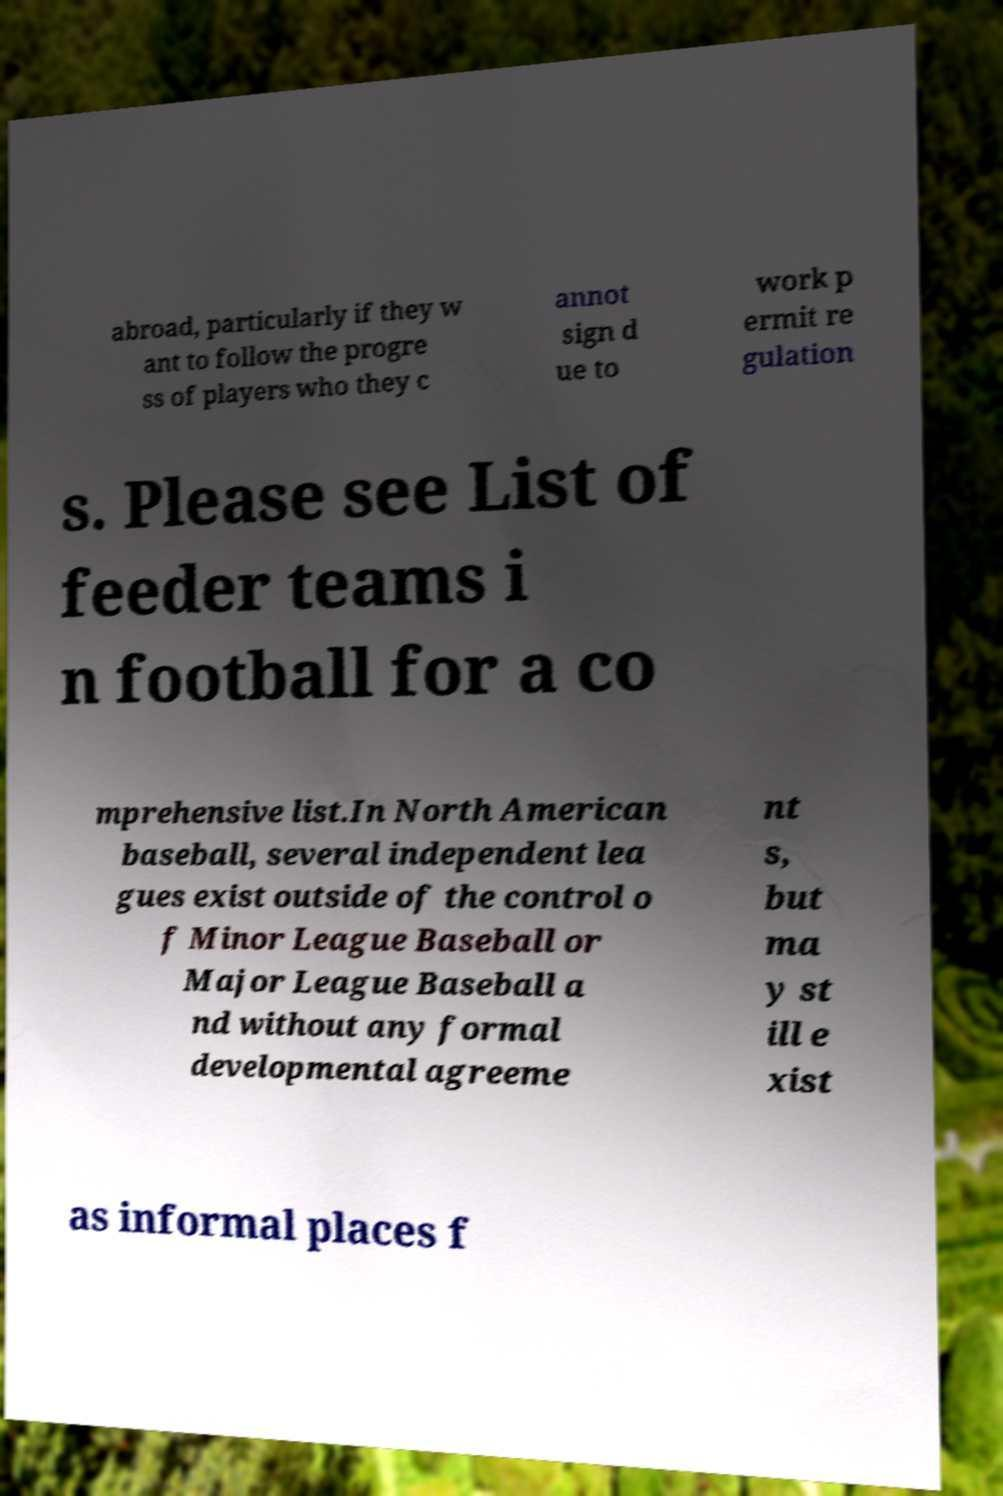Can you accurately transcribe the text from the provided image for me? abroad, particularly if they w ant to follow the progre ss of players who they c annot sign d ue to work p ermit re gulation s. Please see List of feeder teams i n football for a co mprehensive list.In North American baseball, several independent lea gues exist outside of the control o f Minor League Baseball or Major League Baseball a nd without any formal developmental agreeme nt s, but ma y st ill e xist as informal places f 